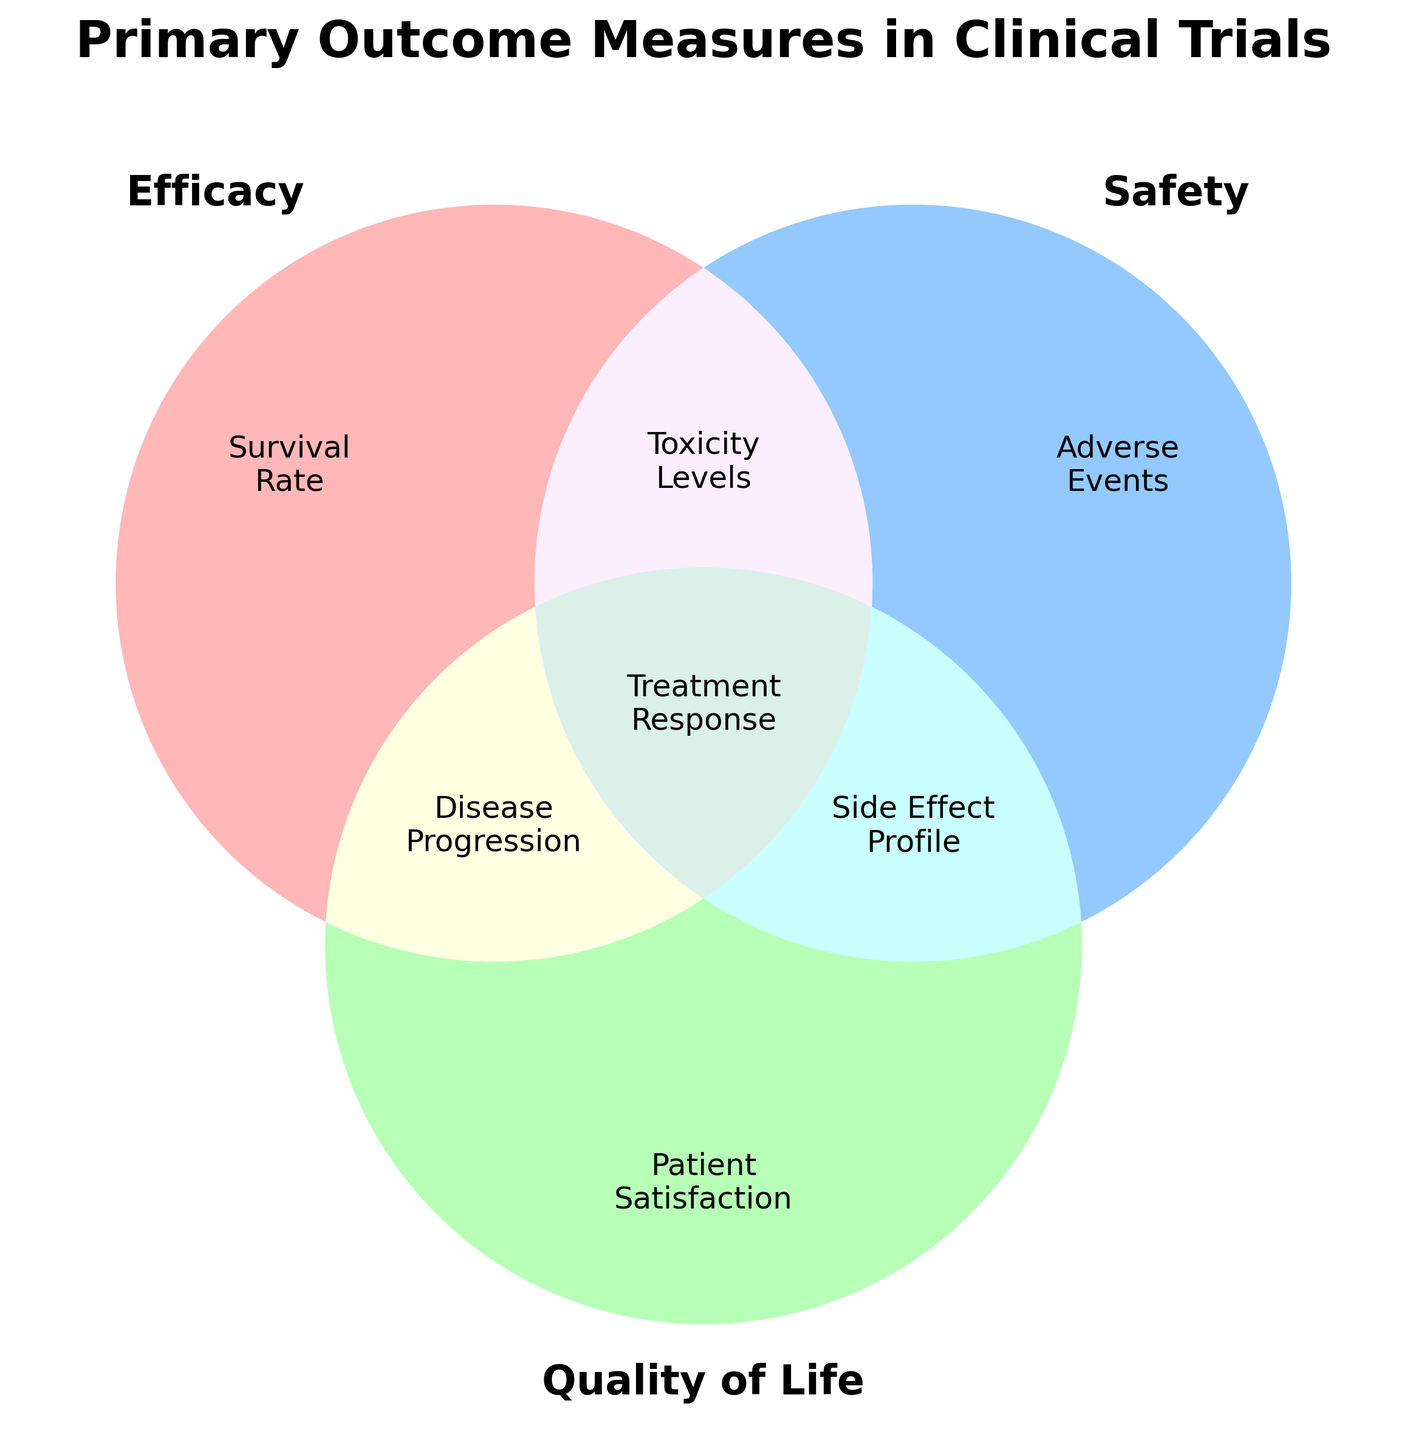What is the title of the figure? The title is typically displayed at the top of the figure and describes the main purpose or content being illustrated.
Answer: Primary Outcome Measures in Clinical Trials Which section represents only Efficacy? In the Venn diagram, the area labeled "100" represents only Efficacy-related outcomes.
Answer: Survival Rate What are the outcomes shared between Safety and Quality of Life only? The section where the sets of Safety and Quality of Life overlap, but not Efficacy, is labeled "011." This area contains outcomes shared only between Safety and Quality of Life.
Answer: Side Effect Profile Which primary outcome measure is common to all three categories? In the Venn diagram, the center area where all three sets overlap is labeled "111," indicating outcomes that are common to Efficacy, Safety, and Quality of Life.
Answer: Treatment Response Compare the overlaps between Efficacy & Safety and Efficacy & Quality of Life. Which has more outcome measures? One needs to refer to the areas labeled "110" and "101" to compare. "110" (Efficacy & Safety) and "101" (Efficacy & Quality of Life). Count the number of outcomes in each to compare.
Answer: Efficacy & Safety (Toxicity Levels) How many outcome measures are unique to Safety? The unique area for Safety, without overlap with Efficacy or Quality of Life, is labeled "010." Count the number of items in this section.
Answer: Adverse Events What overlap exists between Efficacy and Quality of Life? The section where only Efficacy and Quality of Life intersect, without Safety, is labeled "101." Refer to this area to identify the outcome measure.
Answer: Disease Progression Which category includes Survival Rate, and does it share this measure with Safety or Quality of Life? Survival Rate is in the "100" section indicating it is unique to Efficacy with no overlap with Safety or Quality of Life.
Answer: Efficacy only What set of outcomes contains the most overlap in total categories? The area labeled "111" indicates outcomes that overlap all three categories: Efficacy, Safety, and Quality of Life. This represents the maximum overlap possible in this Venn diagram.
Answer: Treatment Response 